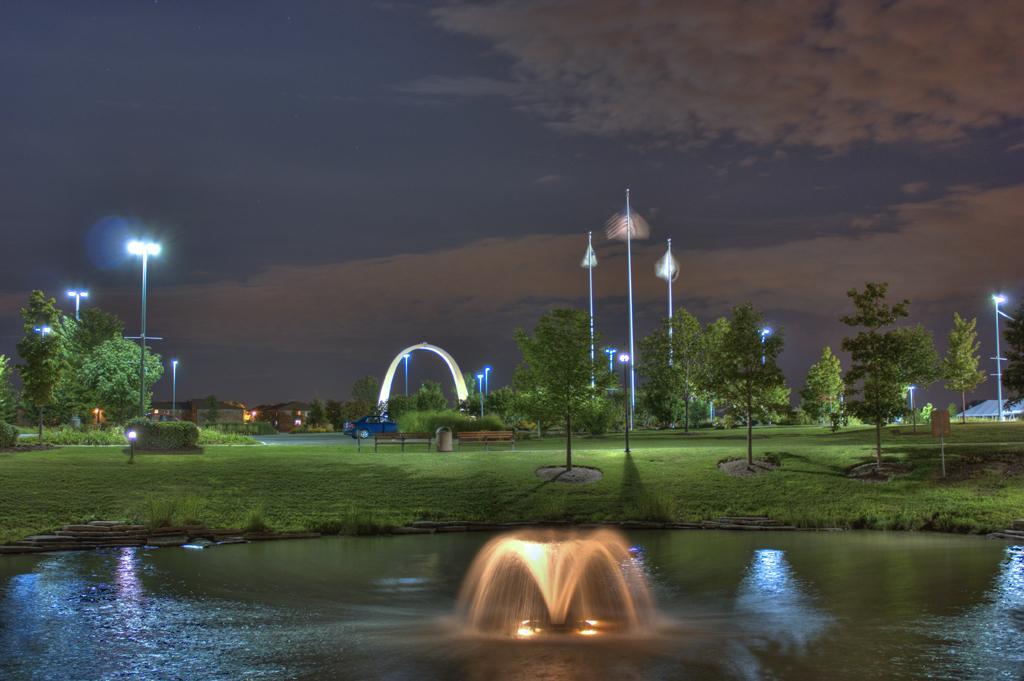Could you give a brief overview of what you see in this image? In this image we can see there is a waterfall with light. And there is a car on the road and an arch. And there are street lights and trees. And there are buildings, Board and a dustbin. And at the top there is a sky. 